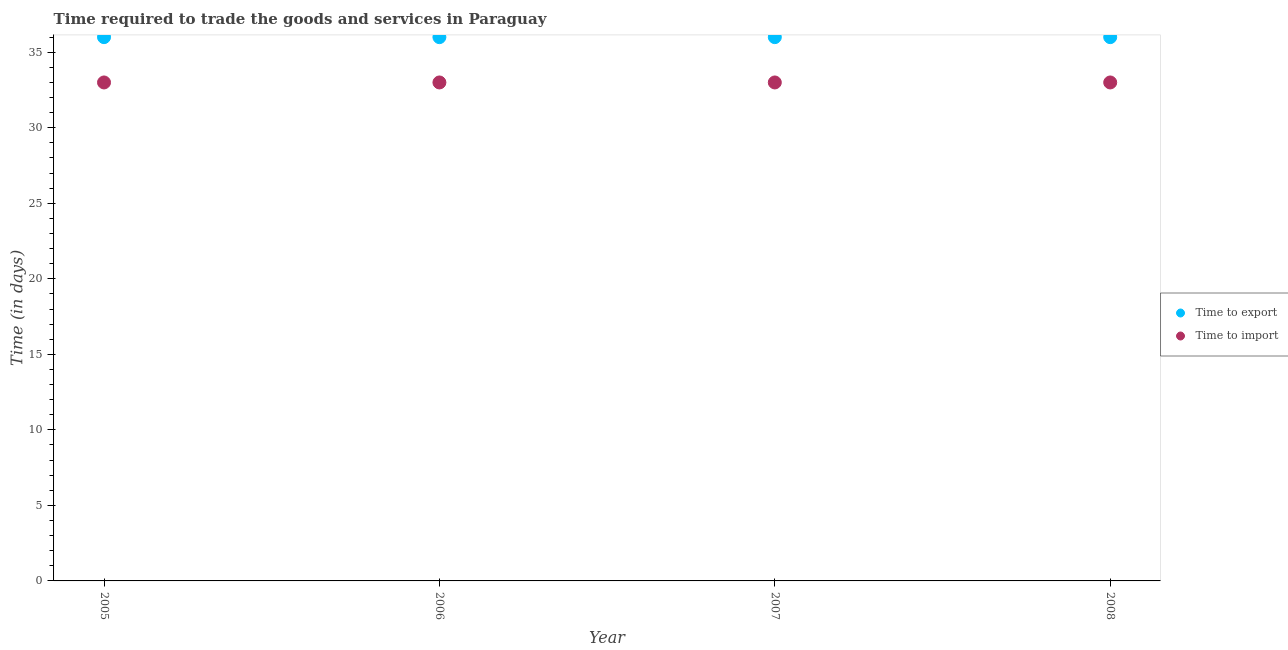How many different coloured dotlines are there?
Provide a short and direct response. 2. Is the number of dotlines equal to the number of legend labels?
Keep it short and to the point. Yes. What is the time to import in 2008?
Offer a very short reply. 33. Across all years, what is the maximum time to import?
Your answer should be compact. 33. Across all years, what is the minimum time to export?
Your answer should be compact. 36. What is the total time to export in the graph?
Make the answer very short. 144. What is the difference between the time to export in 2005 and the time to import in 2008?
Give a very brief answer. 3. What is the average time to export per year?
Provide a succinct answer. 36. In the year 2005, what is the difference between the time to import and time to export?
Your answer should be compact. -3. In how many years, is the time to import greater than 30 days?
Your answer should be very brief. 4. What is the ratio of the time to import in 2005 to that in 2007?
Provide a short and direct response. 1. Is the difference between the time to import in 2006 and 2007 greater than the difference between the time to export in 2006 and 2007?
Ensure brevity in your answer.  No. What is the difference between the highest and the second highest time to export?
Your response must be concise. 0. In how many years, is the time to export greater than the average time to export taken over all years?
Give a very brief answer. 0. Does the time to import monotonically increase over the years?
Keep it short and to the point. No. How many dotlines are there?
Provide a succinct answer. 2. How many years are there in the graph?
Make the answer very short. 4. Are the values on the major ticks of Y-axis written in scientific E-notation?
Give a very brief answer. No. Does the graph contain any zero values?
Your answer should be compact. No. Does the graph contain grids?
Your answer should be very brief. No. How many legend labels are there?
Your answer should be compact. 2. How are the legend labels stacked?
Provide a short and direct response. Vertical. What is the title of the graph?
Provide a short and direct response. Time required to trade the goods and services in Paraguay. Does "Urban" appear as one of the legend labels in the graph?
Provide a short and direct response. No. What is the label or title of the X-axis?
Give a very brief answer. Year. What is the label or title of the Y-axis?
Provide a short and direct response. Time (in days). What is the Time (in days) of Time to export in 2005?
Offer a terse response. 36. What is the Time (in days) of Time to export in 2006?
Your response must be concise. 36. What is the Time (in days) in Time to import in 2006?
Make the answer very short. 33. What is the Time (in days) in Time to export in 2007?
Your answer should be compact. 36. What is the Time (in days) of Time to import in 2007?
Make the answer very short. 33. What is the Time (in days) in Time to import in 2008?
Your answer should be very brief. 33. Across all years, what is the minimum Time (in days) in Time to import?
Make the answer very short. 33. What is the total Time (in days) in Time to export in the graph?
Provide a short and direct response. 144. What is the total Time (in days) in Time to import in the graph?
Your answer should be very brief. 132. What is the difference between the Time (in days) of Time to export in 2005 and that in 2006?
Your answer should be very brief. 0. What is the difference between the Time (in days) of Time to export in 2005 and that in 2008?
Offer a very short reply. 0. What is the difference between the Time (in days) in Time to import in 2006 and that in 2007?
Your answer should be compact. 0. What is the difference between the Time (in days) in Time to import in 2006 and that in 2008?
Provide a short and direct response. 0. What is the difference between the Time (in days) of Time to import in 2007 and that in 2008?
Give a very brief answer. 0. What is the difference between the Time (in days) of Time to export in 2005 and the Time (in days) of Time to import in 2006?
Make the answer very short. 3. What is the difference between the Time (in days) in Time to export in 2005 and the Time (in days) in Time to import in 2008?
Offer a terse response. 3. What is the average Time (in days) in Time to import per year?
Ensure brevity in your answer.  33. In the year 2005, what is the difference between the Time (in days) in Time to export and Time (in days) in Time to import?
Give a very brief answer. 3. In the year 2006, what is the difference between the Time (in days) in Time to export and Time (in days) in Time to import?
Give a very brief answer. 3. In the year 2008, what is the difference between the Time (in days) in Time to export and Time (in days) in Time to import?
Offer a very short reply. 3. What is the ratio of the Time (in days) in Time to export in 2005 to that in 2006?
Provide a short and direct response. 1. What is the ratio of the Time (in days) of Time to import in 2005 to that in 2006?
Provide a short and direct response. 1. What is the ratio of the Time (in days) in Time to export in 2005 to that in 2007?
Your answer should be very brief. 1. What is the ratio of the Time (in days) of Time to export in 2006 to that in 2007?
Make the answer very short. 1. What is the ratio of the Time (in days) in Time to import in 2006 to that in 2007?
Provide a succinct answer. 1. What is the ratio of the Time (in days) in Time to import in 2006 to that in 2008?
Ensure brevity in your answer.  1. What is the ratio of the Time (in days) in Time to export in 2007 to that in 2008?
Your answer should be very brief. 1. What is the difference between the highest and the second highest Time (in days) of Time to import?
Your answer should be very brief. 0. What is the difference between the highest and the lowest Time (in days) of Time to export?
Your answer should be very brief. 0. 